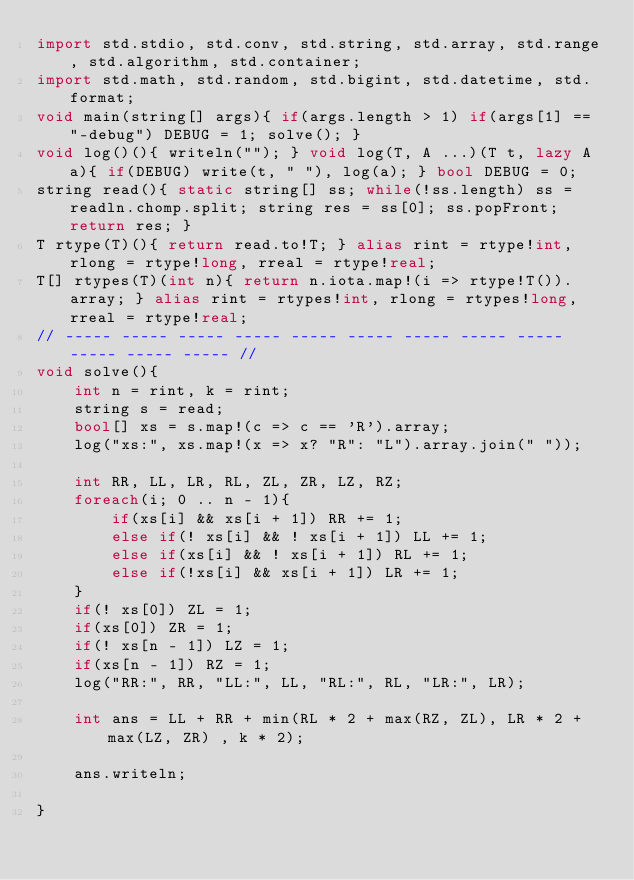<code> <loc_0><loc_0><loc_500><loc_500><_D_>import std.stdio, std.conv, std.string, std.array, std.range, std.algorithm, std.container;
import std.math, std.random, std.bigint, std.datetime, std.format;
void main(string[] args){ if(args.length > 1) if(args[1] == "-debug") DEBUG = 1; solve(); }
void log()(){ writeln(""); } void log(T, A ...)(T t, lazy A a){ if(DEBUG) write(t, " "), log(a); } bool DEBUG = 0;
string read(){ static string[] ss; while(!ss.length) ss = readln.chomp.split; string res = ss[0]; ss.popFront; return res; }
T rtype(T)(){ return read.to!T; } alias rint = rtype!int, rlong = rtype!long, rreal = rtype!real;
T[] rtypes(T)(int n){ return n.iota.map!(i => rtype!T()).array; } alias rint = rtypes!int, rlong = rtypes!long, rreal = rtype!real;
// ----- ----- ----- ----- ----- ----- ----- ----- ----- ----- ----- ----- //
void solve(){
	int n = rint, k = rint;
	string s = read;
	bool[] xs = s.map!(c => c == 'R').array;
	log("xs:", xs.map!(x => x? "R": "L").array.join(" "));
	
	int RR, LL, LR, RL, ZL, ZR, LZ, RZ;
	foreach(i; 0 .. n - 1){
		if(xs[i] && xs[i + 1]) RR += 1;
		else if(! xs[i] && ! xs[i + 1]) LL += 1;
		else if(xs[i] && ! xs[i + 1]) RL += 1;
		else if(!xs[i] && xs[i + 1]) LR += 1;
	}
	if(! xs[0]) ZL = 1;
	if(xs[0]) ZR = 1;
	if(! xs[n - 1]) LZ = 1;
	if(xs[n - 1]) RZ = 1;
	log("RR:", RR, "LL:", LL, "RL:", RL, "LR:", LR);
	
	int ans = LL + RR + min(RL * 2 + max(RZ, ZL), LR * 2 + max(LZ, ZR) , k * 2);
	
	ans.writeln;
	
}
</code> 